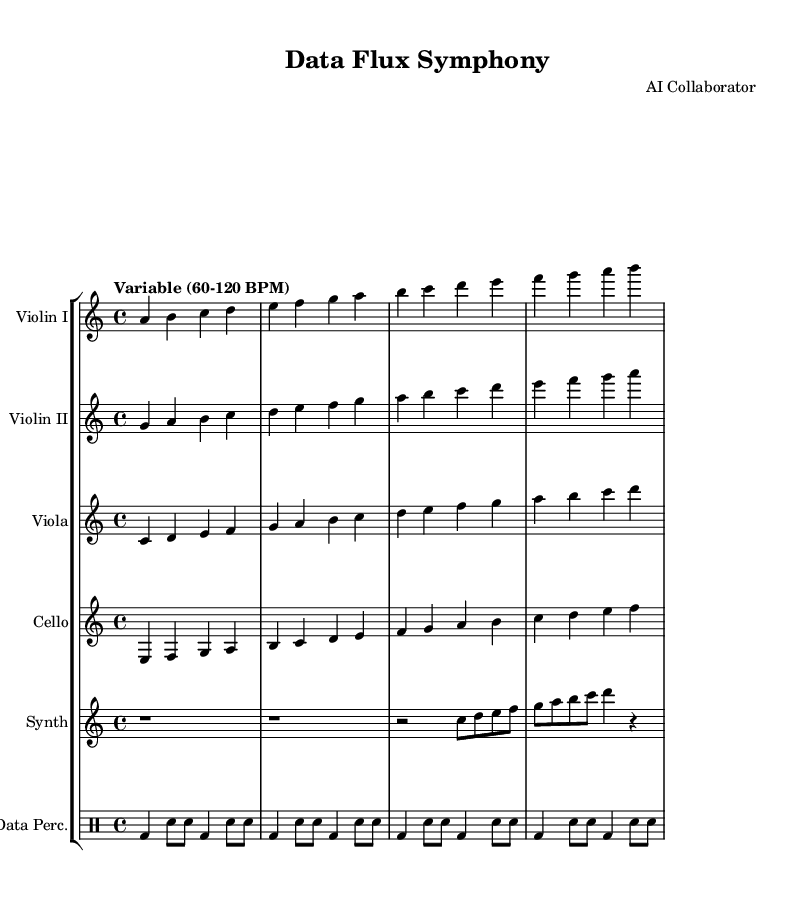What is the time signature of this music? The time signature is indicated at the beginning of the score as 4/4, which means there are four beats in each measure and the quarter note gets one beat.
Answer: 4/4 What tempo is indicated for this composition? The tempo is described as "Variable (60-120 BPM)," which suggests that the piece can be played at any speed within this range, allowing for flexibility in performance.
Answer: Variable (60-120 BPM) How many instruments are featured in this score? By examining the score, there are a total of six distinct parts for instruments listed: Violin I, Violin II, Viola, Cello, Synth, and Data Percussion; creating a total of six instruments.
Answer: Six What is the instrument used for the synthesizer part? The synthesizer part specifies the MIDI instrument as "lead 2 (sawtooth)," indicating that it uses a specific sound characteristic for its notes.
Answer: lead 2 (sawtooth) What rhythmic pattern is used in the percussion section? Analyzing the percussion part, it consists of a repeated pattern primarily featuring bass drum (bd) and snare (sn) notes, with accented beats that create a distinct rhythmic motif.
Answer: bd and sn pattern What is the highest pitch in the Violin I part? Looking at the notes in the Violin I part, the highest pitch reached is the note "d," which occurs at the end of the sequence provided in the score.
Answer: d What characteristic of this piece suggests an experimental style? The use of variable tempo and incorporation of a synthesizer indicates an experimental approach, showcasing flexibility and blending traditional orchestration with electronic elements.
Answer: Variable tempo and synthesizer 